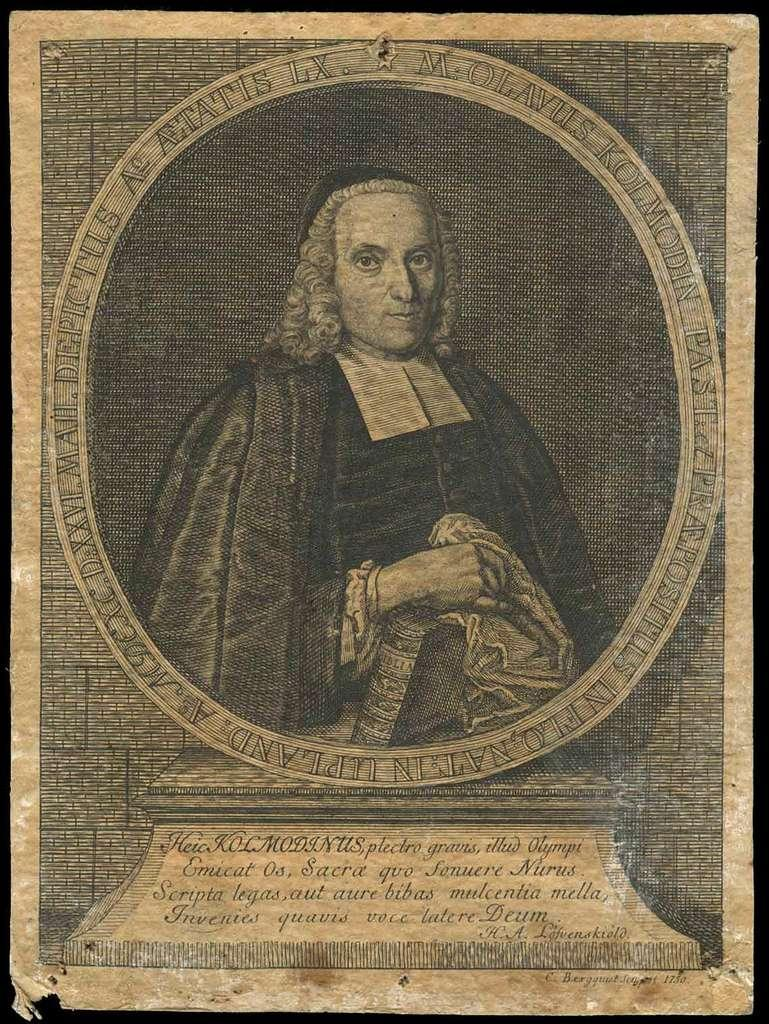Provide a one-sentence caption for the provided image. An image from a book published in 1750 shows a man surrounded by a circle of text. 